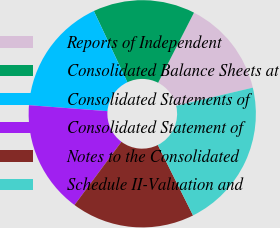Convert chart to OTSL. <chart><loc_0><loc_0><loc_500><loc_500><pie_chart><fcel>Reports of Independent<fcel>Consolidated Balance Sheets at<fcel>Consolidated Statements of<fcel>Consolidated Statement of<fcel>Notes to the Consolidated<fcel>Schedule II-Valuation and<nl><fcel>13.78%<fcel>14.53%<fcel>16.79%<fcel>16.04%<fcel>17.55%<fcel>21.32%<nl></chart> 